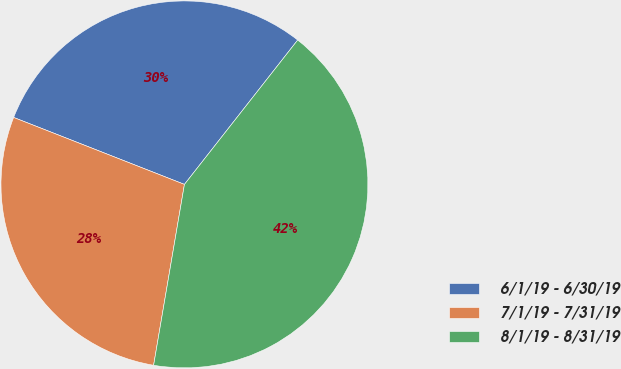Convert chart to OTSL. <chart><loc_0><loc_0><loc_500><loc_500><pie_chart><fcel>6/1/19 - 6/30/19<fcel>7/1/19 - 7/31/19<fcel>8/1/19 - 8/31/19<nl><fcel>29.64%<fcel>28.26%<fcel>42.1%<nl></chart> 